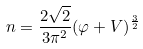Convert formula to latex. <formula><loc_0><loc_0><loc_500><loc_500>n = \frac { 2 \sqrt { 2 } } { 3 \pi ^ { 2 } } ( \varphi + V ) ^ { \frac { 3 } { 2 } }</formula> 